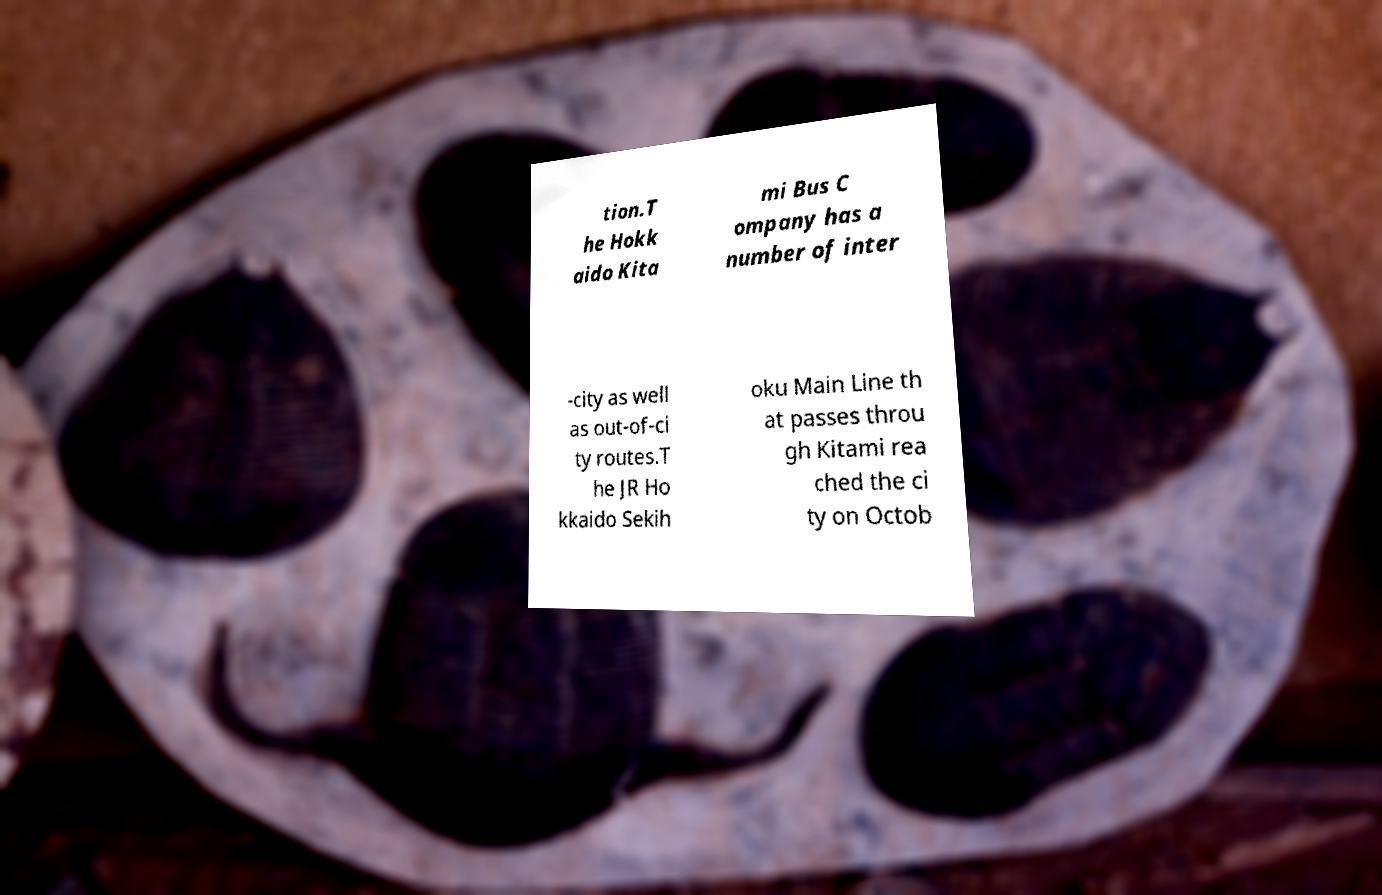For documentation purposes, I need the text within this image transcribed. Could you provide that? tion.T he Hokk aido Kita mi Bus C ompany has a number of inter -city as well as out-of-ci ty routes.T he JR Ho kkaido Sekih oku Main Line th at passes throu gh Kitami rea ched the ci ty on Octob 